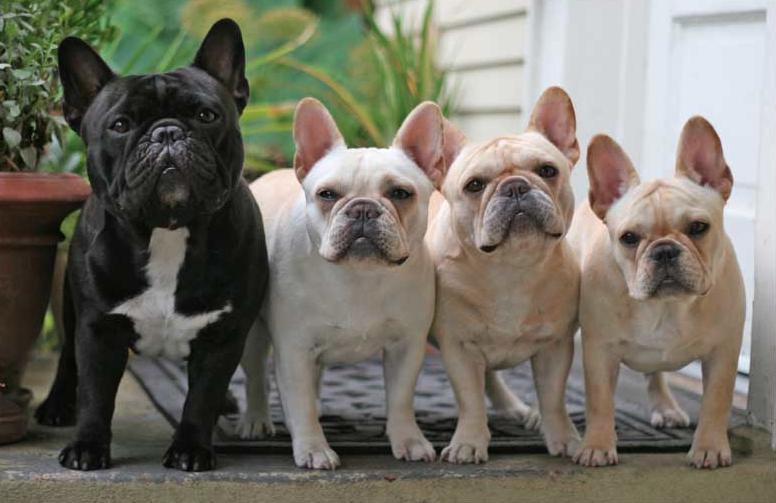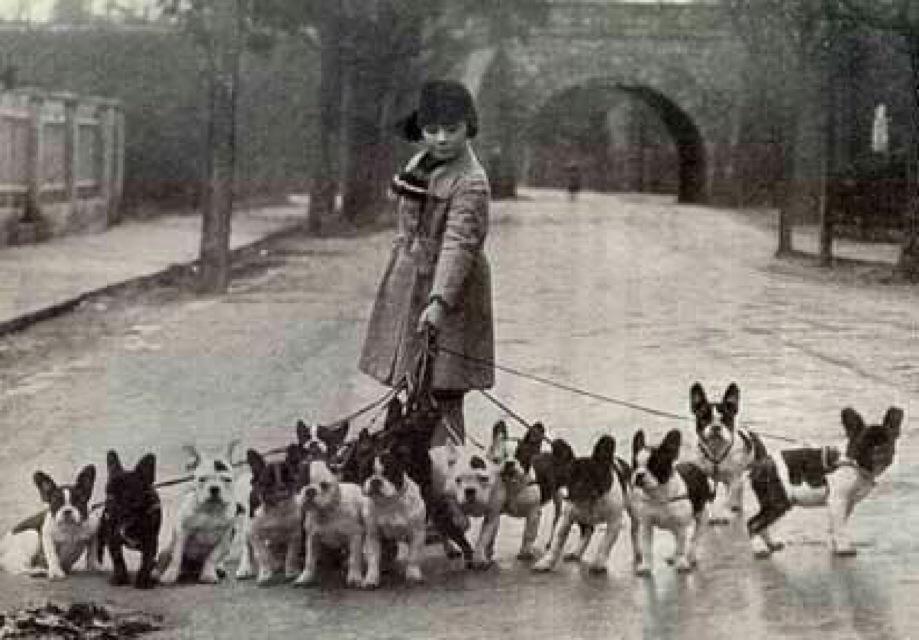The first image is the image on the left, the second image is the image on the right. Analyze the images presented: Is the assertion "The left image contains no more than three dogs." valid? Answer yes or no. No. The first image is the image on the left, the second image is the image on the right. Analyze the images presented: Is the assertion "There is only one dog in one of the images." valid? Answer yes or no. No. 